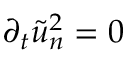<formula> <loc_0><loc_0><loc_500><loc_500>\partial _ { t } \tilde { u } _ { n } ^ { 2 } = 0</formula> 